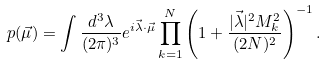Convert formula to latex. <formula><loc_0><loc_0><loc_500><loc_500>p ( \vec { \mu } ) = \int \frac { d ^ { 3 } \lambda } { ( 2 \pi ) ^ { 3 } } e ^ { i \vec { \lambda } \cdot \vec { \mu } } \prod _ { k = 1 } ^ { N } \left ( 1 + \frac { | \vec { \lambda } | ^ { 2 } M _ { k } ^ { 2 } } { ( 2 N ) ^ { 2 } } \right ) ^ { - 1 } .</formula> 